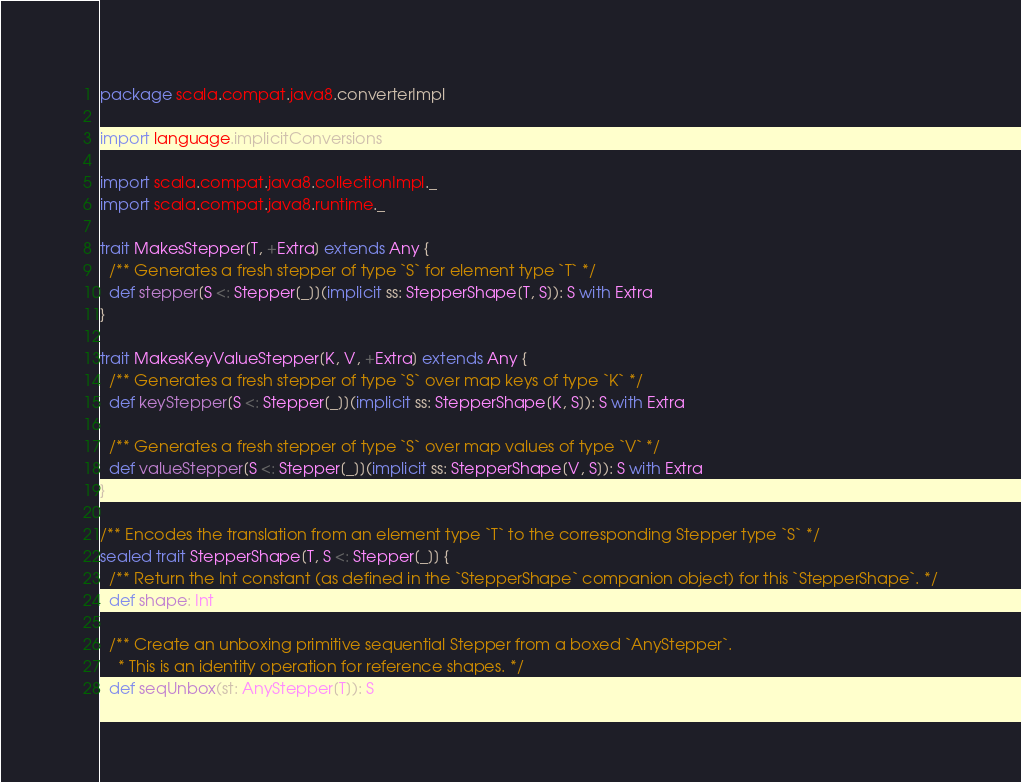<code> <loc_0><loc_0><loc_500><loc_500><_Scala_>package scala.compat.java8.converterImpl

import language.implicitConversions

import scala.compat.java8.collectionImpl._
import scala.compat.java8.runtime._

trait MakesStepper[T, +Extra] extends Any {
  /** Generates a fresh stepper of type `S` for element type `T` */
  def stepper[S <: Stepper[_]](implicit ss: StepperShape[T, S]): S with Extra
}

trait MakesKeyValueStepper[K, V, +Extra] extends Any {
  /** Generates a fresh stepper of type `S` over map keys of type `K` */
  def keyStepper[S <: Stepper[_]](implicit ss: StepperShape[K, S]): S with Extra

  /** Generates a fresh stepper of type `S` over map values of type `V` */
  def valueStepper[S <: Stepper[_]](implicit ss: StepperShape[V, S]): S with Extra
}

/** Encodes the translation from an element type `T` to the corresponding Stepper type `S` */
sealed trait StepperShape[T, S <: Stepper[_]] {
  /** Return the Int constant (as defined in the `StepperShape` companion object) for this `StepperShape`. */
  def shape: Int

  /** Create an unboxing primitive sequential Stepper from a boxed `AnyStepper`.
    * This is an identity operation for reference shapes. */
  def seqUnbox(st: AnyStepper[T]): S
</code> 